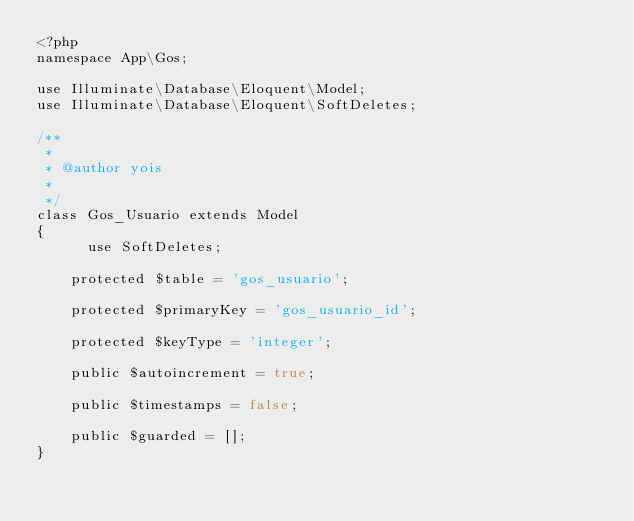<code> <loc_0><loc_0><loc_500><loc_500><_PHP_><?php
namespace App\Gos;

use Illuminate\Database\Eloquent\Model;
use Illuminate\Database\Eloquent\SoftDeletes;

/**
 *
 * @author yois
 *
 */
class Gos_Usuario extends Model
{
      use SoftDeletes;
      
    protected $table = 'gos_usuario';

    protected $primaryKey = 'gos_usuario_id';

    protected $keyType = 'integer';

    public $autoincrement = true;

    public $timestamps = false;

    public $guarded = [];
}
</code> 